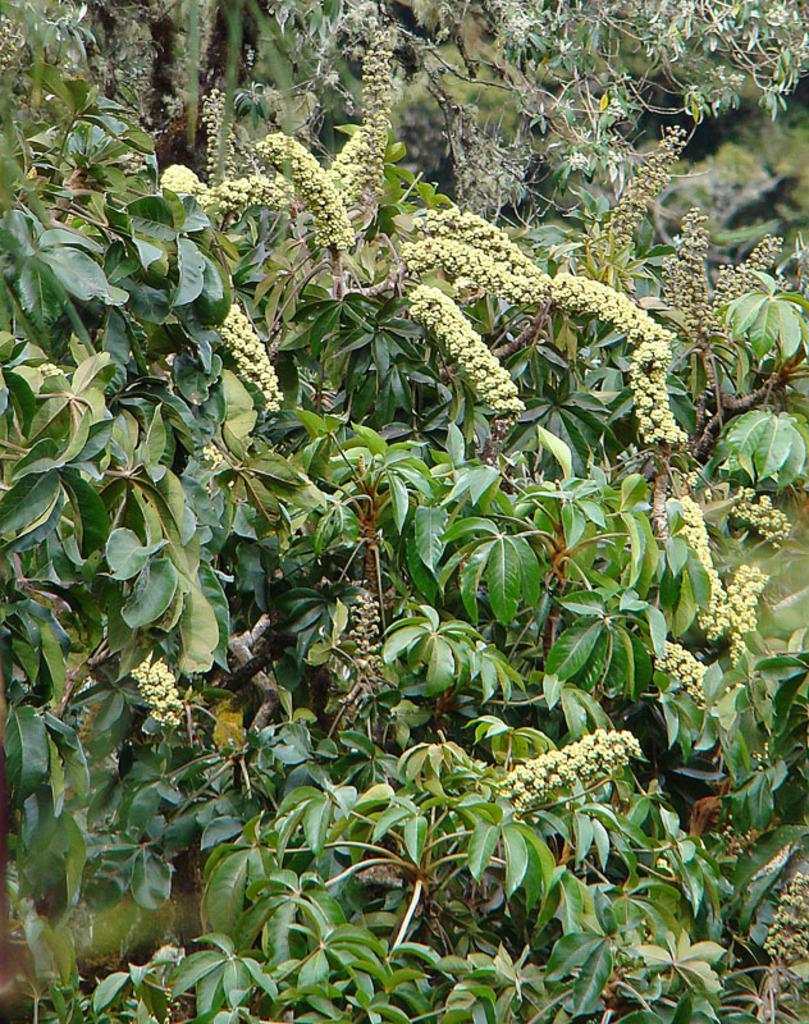In one or two sentences, can you explain what this image depicts? In this picture we can see the leaves and the buds of a tree. In the background there are trees. 